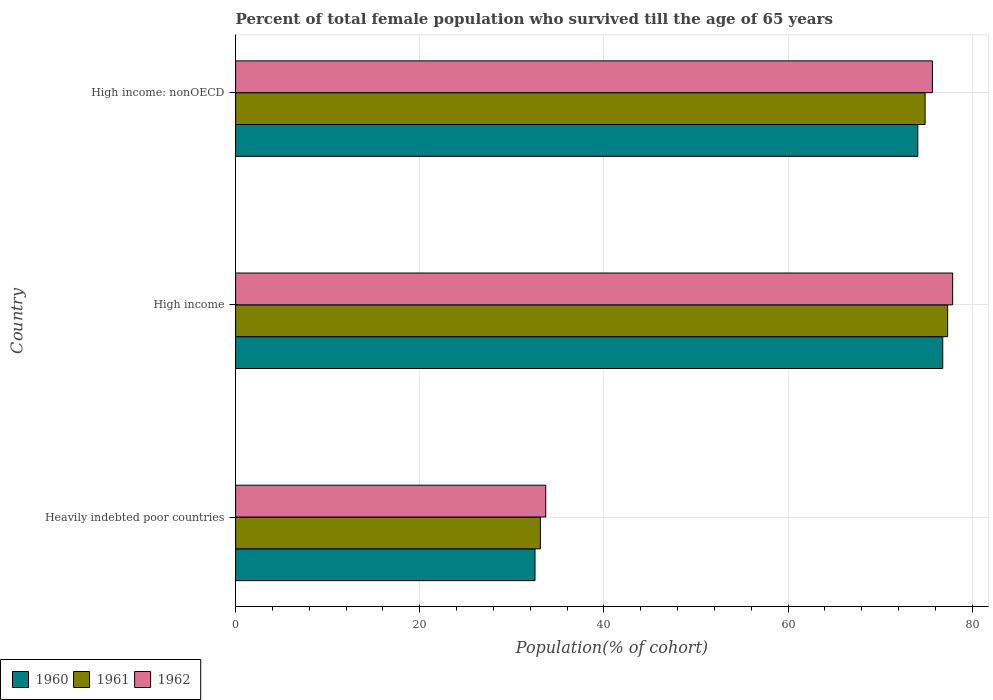How many different coloured bars are there?
Give a very brief answer. 3. Are the number of bars per tick equal to the number of legend labels?
Offer a very short reply. Yes. Are the number of bars on each tick of the Y-axis equal?
Your answer should be very brief. Yes. How many bars are there on the 3rd tick from the bottom?
Provide a succinct answer. 3. What is the percentage of total female population who survived till the age of 65 years in 1960 in High income?
Provide a succinct answer. 76.81. Across all countries, what is the maximum percentage of total female population who survived till the age of 65 years in 1960?
Keep it short and to the point. 76.81. Across all countries, what is the minimum percentage of total female population who survived till the age of 65 years in 1961?
Offer a terse response. 33.1. In which country was the percentage of total female population who survived till the age of 65 years in 1962 minimum?
Make the answer very short. Heavily indebted poor countries. What is the total percentage of total female population who survived till the age of 65 years in 1961 in the graph?
Offer a very short reply. 185.34. What is the difference between the percentage of total female population who survived till the age of 65 years in 1961 in High income and that in High income: nonOECD?
Offer a very short reply. 2.45. What is the difference between the percentage of total female population who survived till the age of 65 years in 1961 in Heavily indebted poor countries and the percentage of total female population who survived till the age of 65 years in 1960 in High income: nonOECD?
Your response must be concise. -41. What is the average percentage of total female population who survived till the age of 65 years in 1961 per country?
Provide a succinct answer. 61.78. What is the difference between the percentage of total female population who survived till the age of 65 years in 1960 and percentage of total female population who survived till the age of 65 years in 1962 in Heavily indebted poor countries?
Make the answer very short. -1.17. What is the ratio of the percentage of total female population who survived till the age of 65 years in 1960 in Heavily indebted poor countries to that in High income: nonOECD?
Offer a very short reply. 0.44. Is the percentage of total female population who survived till the age of 65 years in 1961 in Heavily indebted poor countries less than that in High income?
Your response must be concise. Yes. Is the difference between the percentage of total female population who survived till the age of 65 years in 1960 in Heavily indebted poor countries and High income greater than the difference between the percentage of total female population who survived till the age of 65 years in 1962 in Heavily indebted poor countries and High income?
Ensure brevity in your answer.  No. What is the difference between the highest and the second highest percentage of total female population who survived till the age of 65 years in 1960?
Ensure brevity in your answer.  2.71. What is the difference between the highest and the lowest percentage of total female population who survived till the age of 65 years in 1961?
Offer a very short reply. 44.24. Is the sum of the percentage of total female population who survived till the age of 65 years in 1962 in Heavily indebted poor countries and High income: nonOECD greater than the maximum percentage of total female population who survived till the age of 65 years in 1961 across all countries?
Offer a very short reply. Yes. What does the 3rd bar from the top in High income: nonOECD represents?
Ensure brevity in your answer.  1960. What does the 3rd bar from the bottom in Heavily indebted poor countries represents?
Offer a very short reply. 1962. Is it the case that in every country, the sum of the percentage of total female population who survived till the age of 65 years in 1962 and percentage of total female population who survived till the age of 65 years in 1960 is greater than the percentage of total female population who survived till the age of 65 years in 1961?
Your answer should be very brief. Yes. What is the difference between two consecutive major ticks on the X-axis?
Your response must be concise. 20. How many legend labels are there?
Offer a very short reply. 3. What is the title of the graph?
Ensure brevity in your answer.  Percent of total female population who survived till the age of 65 years. Does "1970" appear as one of the legend labels in the graph?
Offer a very short reply. No. What is the label or title of the X-axis?
Provide a short and direct response. Population(% of cohort). What is the label or title of the Y-axis?
Make the answer very short. Country. What is the Population(% of cohort) of 1960 in Heavily indebted poor countries?
Offer a terse response. 32.52. What is the Population(% of cohort) in 1961 in Heavily indebted poor countries?
Your answer should be very brief. 33.1. What is the Population(% of cohort) of 1962 in Heavily indebted poor countries?
Your answer should be compact. 33.69. What is the Population(% of cohort) of 1960 in High income?
Your answer should be compact. 76.81. What is the Population(% of cohort) in 1961 in High income?
Provide a succinct answer. 77.34. What is the Population(% of cohort) in 1962 in High income?
Give a very brief answer. 77.88. What is the Population(% of cohort) in 1960 in High income: nonOECD?
Give a very brief answer. 74.1. What is the Population(% of cohort) in 1961 in High income: nonOECD?
Give a very brief answer. 74.89. What is the Population(% of cohort) of 1962 in High income: nonOECD?
Give a very brief answer. 75.69. Across all countries, what is the maximum Population(% of cohort) of 1960?
Your answer should be compact. 76.81. Across all countries, what is the maximum Population(% of cohort) of 1961?
Keep it short and to the point. 77.34. Across all countries, what is the maximum Population(% of cohort) in 1962?
Give a very brief answer. 77.88. Across all countries, what is the minimum Population(% of cohort) of 1960?
Your answer should be very brief. 32.52. Across all countries, what is the minimum Population(% of cohort) of 1961?
Provide a short and direct response. 33.1. Across all countries, what is the minimum Population(% of cohort) of 1962?
Provide a succinct answer. 33.69. What is the total Population(% of cohort) in 1960 in the graph?
Provide a short and direct response. 183.43. What is the total Population(% of cohort) of 1961 in the graph?
Your answer should be very brief. 185.34. What is the total Population(% of cohort) of 1962 in the graph?
Your answer should be very brief. 187.26. What is the difference between the Population(% of cohort) of 1960 in Heavily indebted poor countries and that in High income?
Your response must be concise. -44.29. What is the difference between the Population(% of cohort) in 1961 in Heavily indebted poor countries and that in High income?
Give a very brief answer. -44.24. What is the difference between the Population(% of cohort) in 1962 in Heavily indebted poor countries and that in High income?
Your answer should be very brief. -44.2. What is the difference between the Population(% of cohort) of 1960 in Heavily indebted poor countries and that in High income: nonOECD?
Your response must be concise. -41.58. What is the difference between the Population(% of cohort) in 1961 in Heavily indebted poor countries and that in High income: nonOECD?
Your answer should be compact. -41.79. What is the difference between the Population(% of cohort) of 1962 in Heavily indebted poor countries and that in High income: nonOECD?
Provide a succinct answer. -42. What is the difference between the Population(% of cohort) of 1960 in High income and that in High income: nonOECD?
Provide a short and direct response. 2.71. What is the difference between the Population(% of cohort) in 1961 in High income and that in High income: nonOECD?
Offer a very short reply. 2.45. What is the difference between the Population(% of cohort) of 1962 in High income and that in High income: nonOECD?
Provide a short and direct response. 2.2. What is the difference between the Population(% of cohort) of 1960 in Heavily indebted poor countries and the Population(% of cohort) of 1961 in High income?
Provide a succinct answer. -44.82. What is the difference between the Population(% of cohort) in 1960 in Heavily indebted poor countries and the Population(% of cohort) in 1962 in High income?
Offer a very short reply. -45.36. What is the difference between the Population(% of cohort) in 1961 in Heavily indebted poor countries and the Population(% of cohort) in 1962 in High income?
Ensure brevity in your answer.  -44.78. What is the difference between the Population(% of cohort) in 1960 in Heavily indebted poor countries and the Population(% of cohort) in 1961 in High income: nonOECD?
Offer a very short reply. -42.37. What is the difference between the Population(% of cohort) of 1960 in Heavily indebted poor countries and the Population(% of cohort) of 1962 in High income: nonOECD?
Give a very brief answer. -43.17. What is the difference between the Population(% of cohort) of 1961 in Heavily indebted poor countries and the Population(% of cohort) of 1962 in High income: nonOECD?
Ensure brevity in your answer.  -42.58. What is the difference between the Population(% of cohort) in 1960 in High income and the Population(% of cohort) in 1961 in High income: nonOECD?
Provide a succinct answer. 1.92. What is the difference between the Population(% of cohort) in 1960 in High income and the Population(% of cohort) in 1962 in High income: nonOECD?
Offer a very short reply. 1.12. What is the difference between the Population(% of cohort) in 1961 in High income and the Population(% of cohort) in 1962 in High income: nonOECD?
Ensure brevity in your answer.  1.65. What is the average Population(% of cohort) in 1960 per country?
Provide a succinct answer. 61.14. What is the average Population(% of cohort) in 1961 per country?
Provide a succinct answer. 61.78. What is the average Population(% of cohort) in 1962 per country?
Your answer should be compact. 62.42. What is the difference between the Population(% of cohort) of 1960 and Population(% of cohort) of 1961 in Heavily indebted poor countries?
Provide a short and direct response. -0.58. What is the difference between the Population(% of cohort) in 1960 and Population(% of cohort) in 1962 in Heavily indebted poor countries?
Provide a short and direct response. -1.17. What is the difference between the Population(% of cohort) in 1961 and Population(% of cohort) in 1962 in Heavily indebted poor countries?
Give a very brief answer. -0.58. What is the difference between the Population(% of cohort) of 1960 and Population(% of cohort) of 1961 in High income?
Your answer should be very brief. -0.53. What is the difference between the Population(% of cohort) in 1960 and Population(% of cohort) in 1962 in High income?
Your answer should be very brief. -1.07. What is the difference between the Population(% of cohort) in 1961 and Population(% of cohort) in 1962 in High income?
Offer a terse response. -0.54. What is the difference between the Population(% of cohort) in 1960 and Population(% of cohort) in 1961 in High income: nonOECD?
Keep it short and to the point. -0.79. What is the difference between the Population(% of cohort) of 1960 and Population(% of cohort) of 1962 in High income: nonOECD?
Your answer should be very brief. -1.59. What is the difference between the Population(% of cohort) in 1961 and Population(% of cohort) in 1962 in High income: nonOECD?
Offer a very short reply. -0.79. What is the ratio of the Population(% of cohort) of 1960 in Heavily indebted poor countries to that in High income?
Provide a succinct answer. 0.42. What is the ratio of the Population(% of cohort) in 1961 in Heavily indebted poor countries to that in High income?
Your answer should be very brief. 0.43. What is the ratio of the Population(% of cohort) of 1962 in Heavily indebted poor countries to that in High income?
Your answer should be compact. 0.43. What is the ratio of the Population(% of cohort) in 1960 in Heavily indebted poor countries to that in High income: nonOECD?
Ensure brevity in your answer.  0.44. What is the ratio of the Population(% of cohort) of 1961 in Heavily indebted poor countries to that in High income: nonOECD?
Give a very brief answer. 0.44. What is the ratio of the Population(% of cohort) in 1962 in Heavily indebted poor countries to that in High income: nonOECD?
Provide a short and direct response. 0.45. What is the ratio of the Population(% of cohort) of 1960 in High income to that in High income: nonOECD?
Ensure brevity in your answer.  1.04. What is the ratio of the Population(% of cohort) in 1961 in High income to that in High income: nonOECD?
Make the answer very short. 1.03. What is the difference between the highest and the second highest Population(% of cohort) in 1960?
Offer a terse response. 2.71. What is the difference between the highest and the second highest Population(% of cohort) in 1961?
Your answer should be very brief. 2.45. What is the difference between the highest and the second highest Population(% of cohort) of 1962?
Provide a short and direct response. 2.2. What is the difference between the highest and the lowest Population(% of cohort) in 1960?
Your response must be concise. 44.29. What is the difference between the highest and the lowest Population(% of cohort) of 1961?
Your answer should be compact. 44.24. What is the difference between the highest and the lowest Population(% of cohort) of 1962?
Keep it short and to the point. 44.2. 